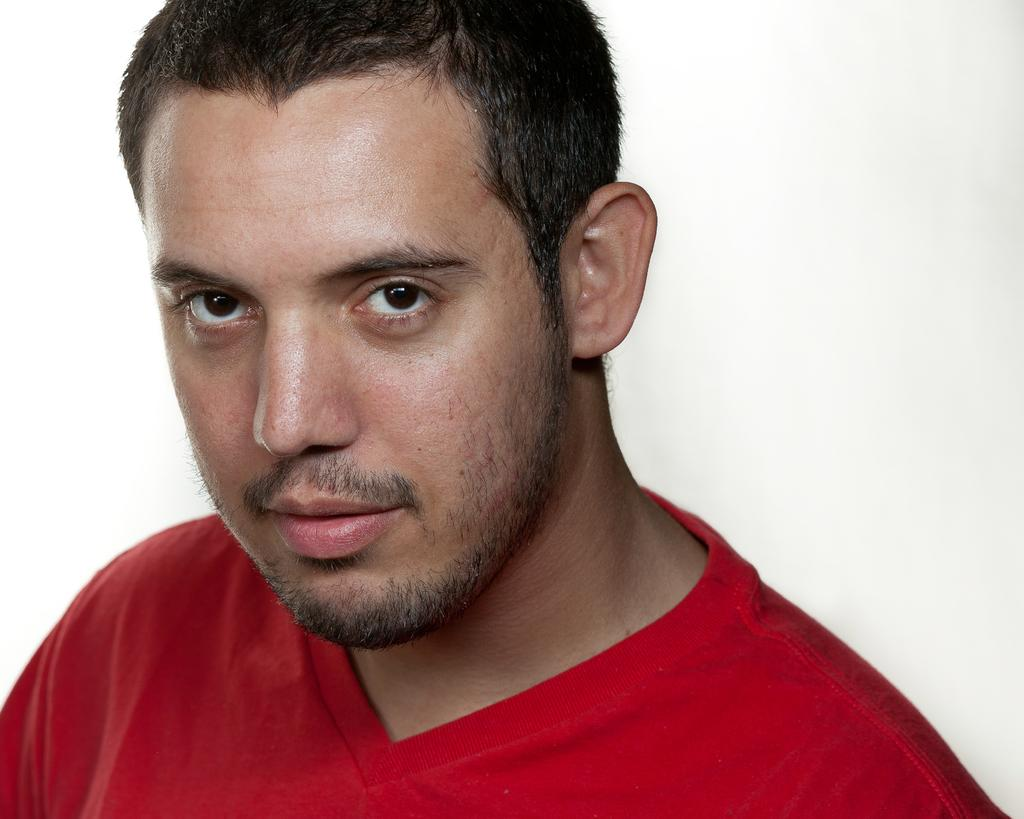Who or what is the main subject in the image? There is a person in the image. What is the person wearing in the image? The person is wearing a red T-shirt. What color is the background of the image? The background of the image is white. What is the weight of the person in the image? The weight of the person cannot be determined from the image, as it is not visible or mentioned in the provided facts. 